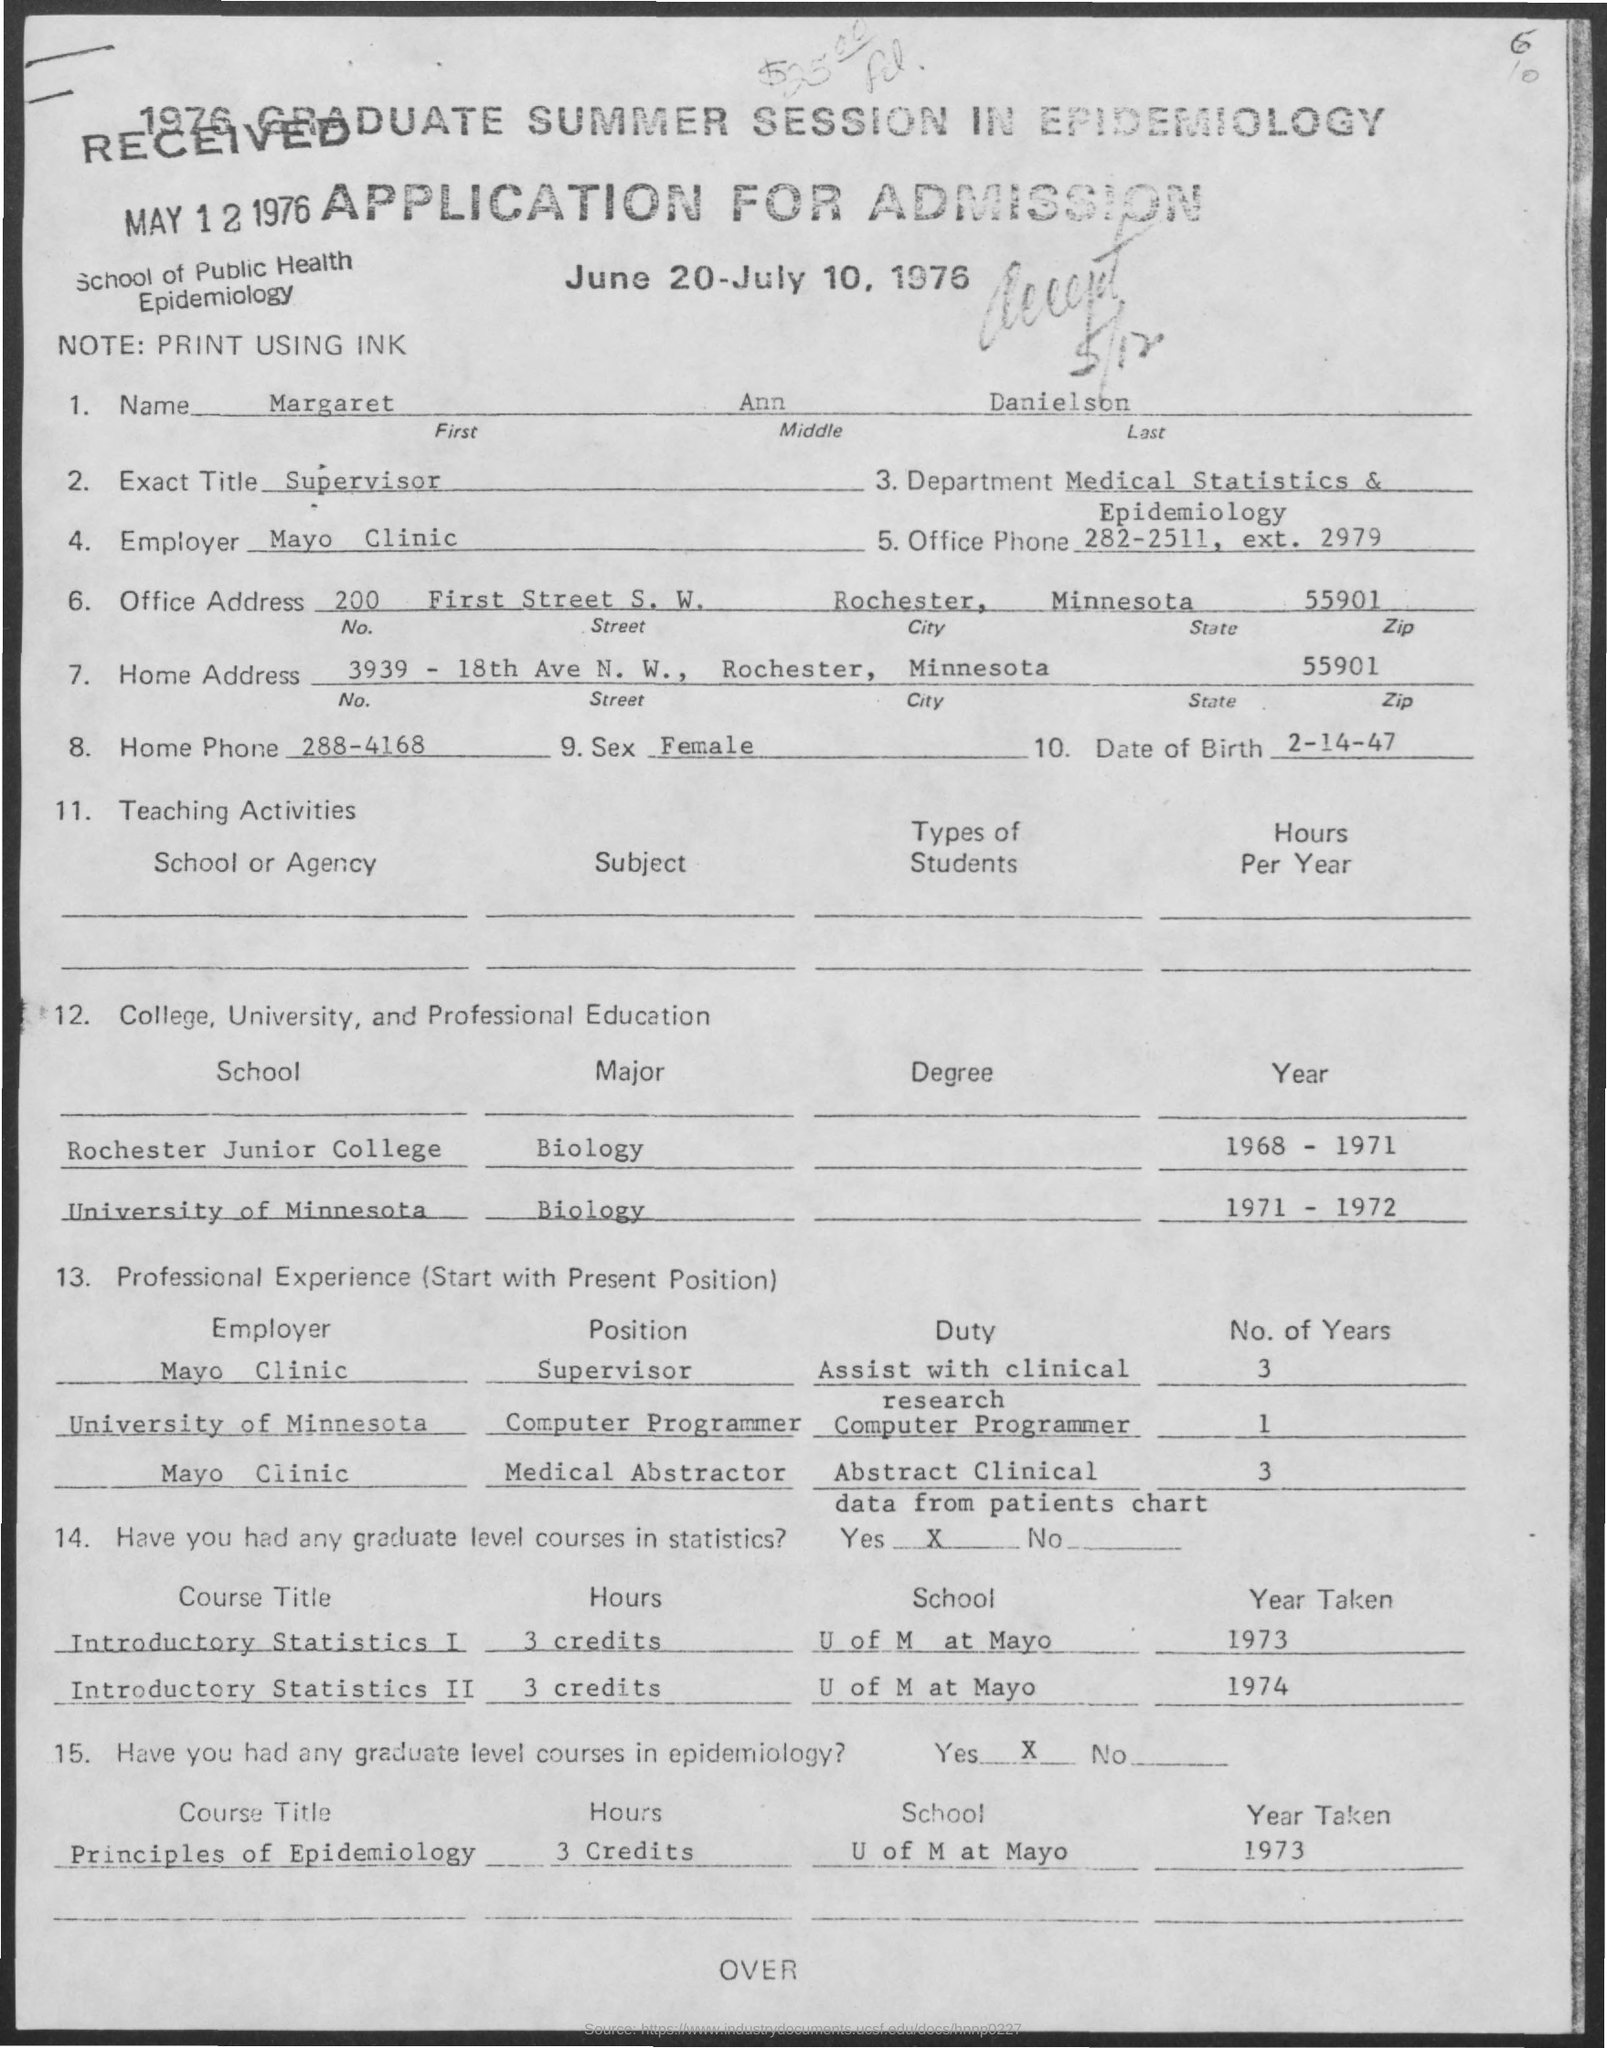Identify some key points in this picture. Margaret Ann Danielson was assigned the duty of assisting with clinical research as a supervisor at Mayo Clinic in May. It is mentioned in the application that Margaret Ann Danielson is employed at the Mayo Clinic. The zip code provided in the home address is 55901. The person's name given in the application is Margaret Ann Danielson. The exact title of Margaret Ann Danielson as given in the application is "Supervisor". 